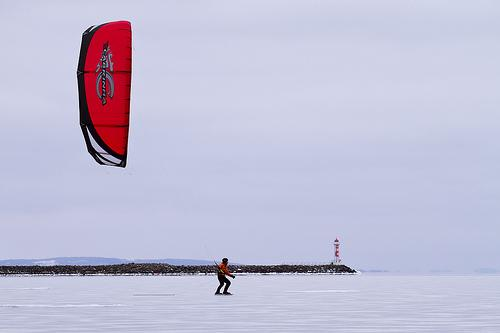Question: when was the picture taken?
Choices:
A. At night.
B. In the early morning.
C. Right before sunset.
D. During the day.
Answer with the letter. Answer: D Question: what is the doing?
Choices:
A. Swimming.
B. Water surfing.
C. Selling hot dogs.
D. Sun bathing.
Answer with the letter. Answer: B Question: what color jacket is the man wearing?
Choices:
A. Red.
B. Black.
C. Brown.
D. Gray.
Answer with the letter. Answer: A Question: where was the picture taken?
Choices:
A. By the lake.
B. In the hall.
C. On the water.
D. In the woods.
Answer with the letter. Answer: C 